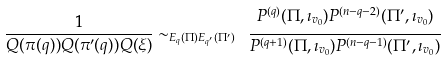<formula> <loc_0><loc_0><loc_500><loc_500>\frac { 1 } { Q ( \pi ( q ) ) Q ( \pi ^ { \prime } ( q ) ) Q ( \xi ) } \sim _ { E _ { q } ( \Pi ) E _ { q ^ { \prime } } ( \Pi ^ { \prime } ) } \ \cfrac { P ^ { ( q ) } ( \Pi , \imath _ { v _ { 0 } } ) P ^ { ( n - q - 2 ) } ( \Pi ^ { \prime } , \imath _ { v _ { 0 } } ) } { P ^ { ( q + 1 ) } ( \Pi , \imath _ { v _ { 0 } } ) P ^ { ( n - q - 1 ) } ( \Pi ^ { \prime } , \imath _ { v _ { 0 } } ) }</formula> 